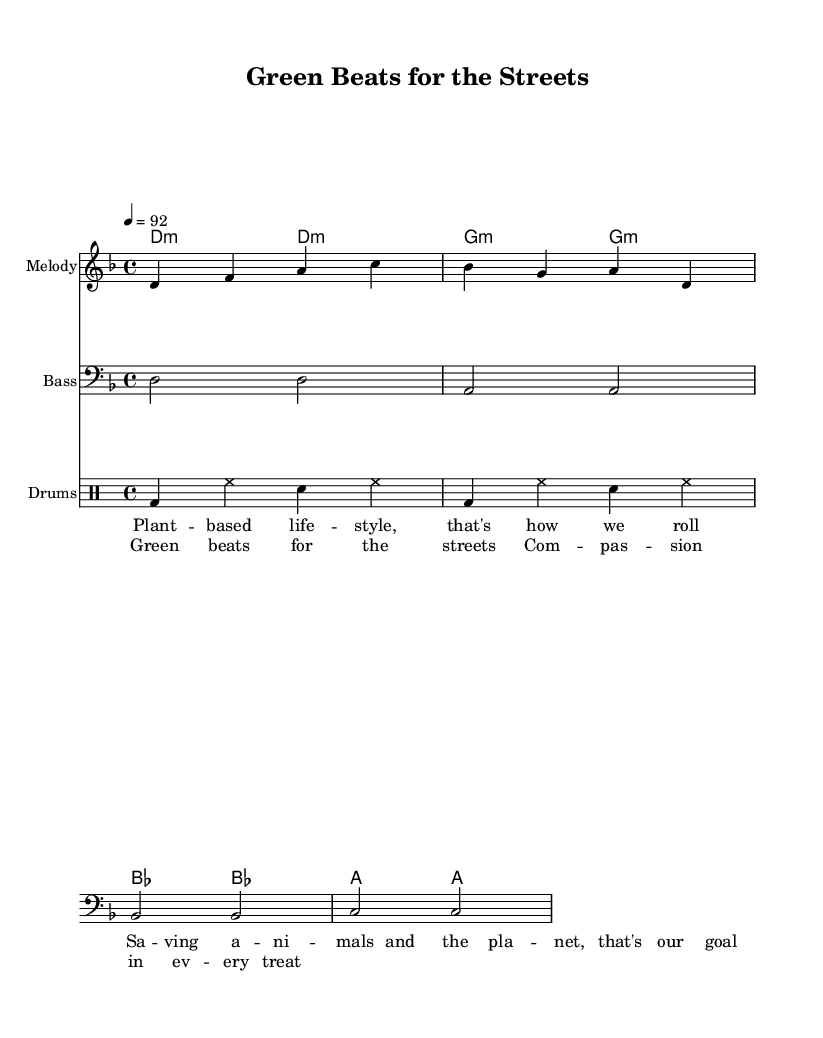What is the key signature of this music? The key signature is represented at the beginning of the score. It shows one flat, indicating that the piece is in D minor.
Answer: D minor What is the time signature of this rap? The time signature is located at the beginning of the score, indicated by the fraction. It shows 4/4, meaning there are four beats per measure with a quarter note receiving one beat.
Answer: 4/4 What is the tempo marking for this piece? The tempo is indicated at the beginning of the score by the number followed by an equal sign. It shows 92, meaning the piece should be played at 92 beats per minute.
Answer: 92 How many measures are in the melody section? To determine the number of measures in the melody, we count the separations between the notes and phrases visually. There are four measures in the melody section as indicated by the structure of the notes.
Answer: 4 What type of style does the lyric promote? The lyrics reference a lifestyle that focuses on compassion towards animals and the environment, specifically advocating for a plant-based lifestyle.
Answer: Plant-based lifestyle How many drum patterns are indicated within the score? The drum section shows a repeating pattern, and by counting the lines in the drum part, we see there are two distinct measures that describe the drum rhythm.
Answer: 2 What is the main theme of the chorus? The lyrics of the chorus highlight compassion and kindness, emphasizing the importance of compassion in every treat. This connects back to the overall theme of promoting a vegan lifestyle.
Answer: Compassion 